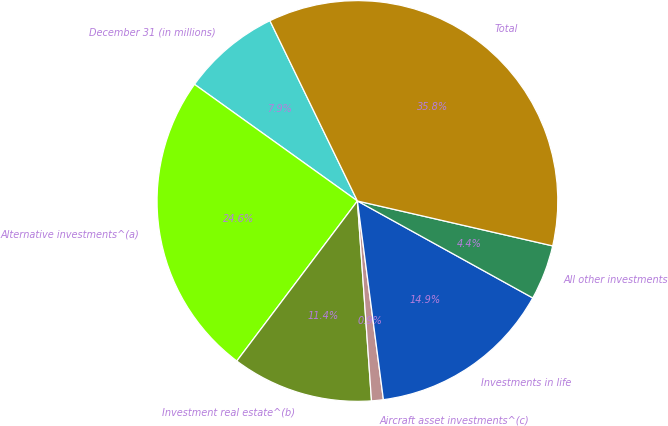Convert chart. <chart><loc_0><loc_0><loc_500><loc_500><pie_chart><fcel>December 31 (in millions)<fcel>Alternative investments^(a)<fcel>Investment real estate^(b)<fcel>Aircraft asset investments^(c)<fcel>Investments in life<fcel>All other investments<fcel>Total<nl><fcel>7.92%<fcel>24.61%<fcel>11.4%<fcel>0.95%<fcel>14.89%<fcel>4.44%<fcel>35.79%<nl></chart> 